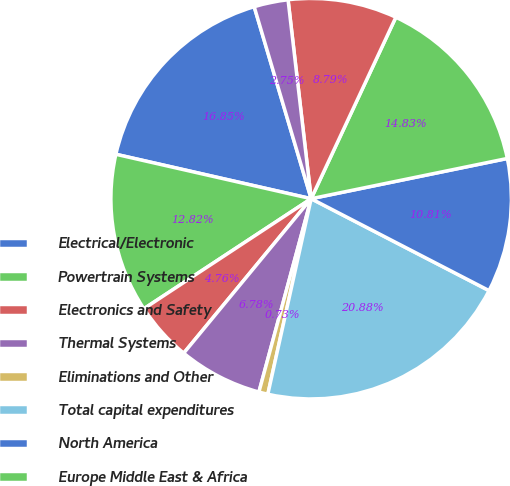Convert chart to OTSL. <chart><loc_0><loc_0><loc_500><loc_500><pie_chart><fcel>Electrical/Electronic<fcel>Powertrain Systems<fcel>Electronics and Safety<fcel>Thermal Systems<fcel>Eliminations and Other<fcel>Total capital expenditures<fcel>North America<fcel>Europe Middle East & Africa<fcel>Asia Pacific<fcel>South America<nl><fcel>16.85%<fcel>12.82%<fcel>4.76%<fcel>6.78%<fcel>0.73%<fcel>20.88%<fcel>10.81%<fcel>14.83%<fcel>8.79%<fcel>2.75%<nl></chart> 